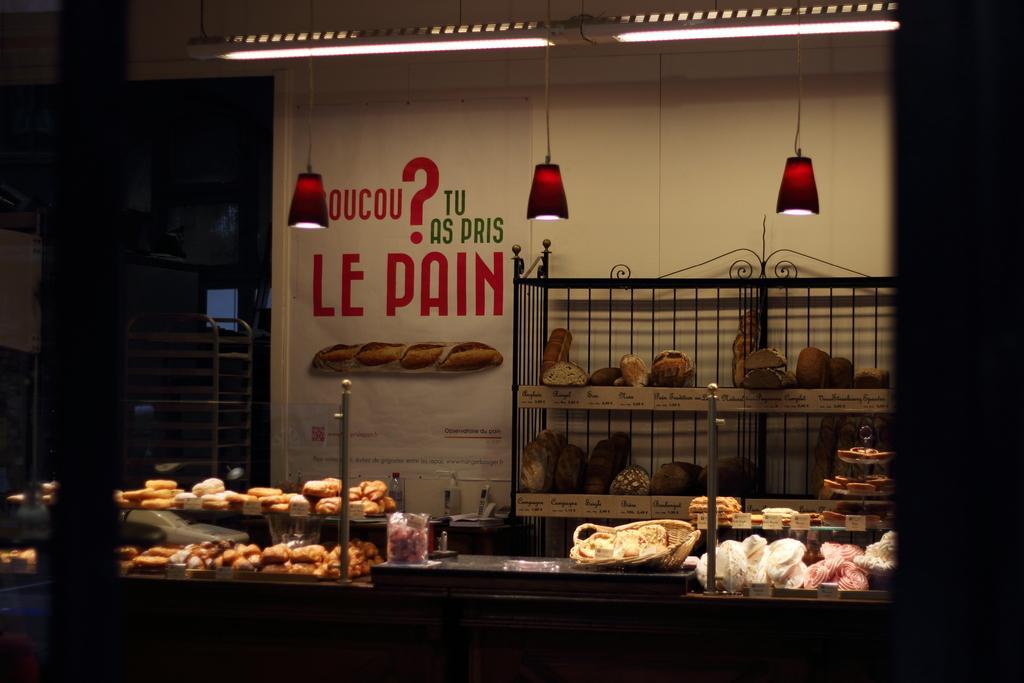Could you give a brief overview of what you see in this image? In this image there is a bakery, in that there are tables on that tables there are bakery items, in the background there are wall to that wall there is a shelf, in that shelf there is food item and there is a text on the wall at the top there are lights, on the left there is an entrance in that there is a stand. 